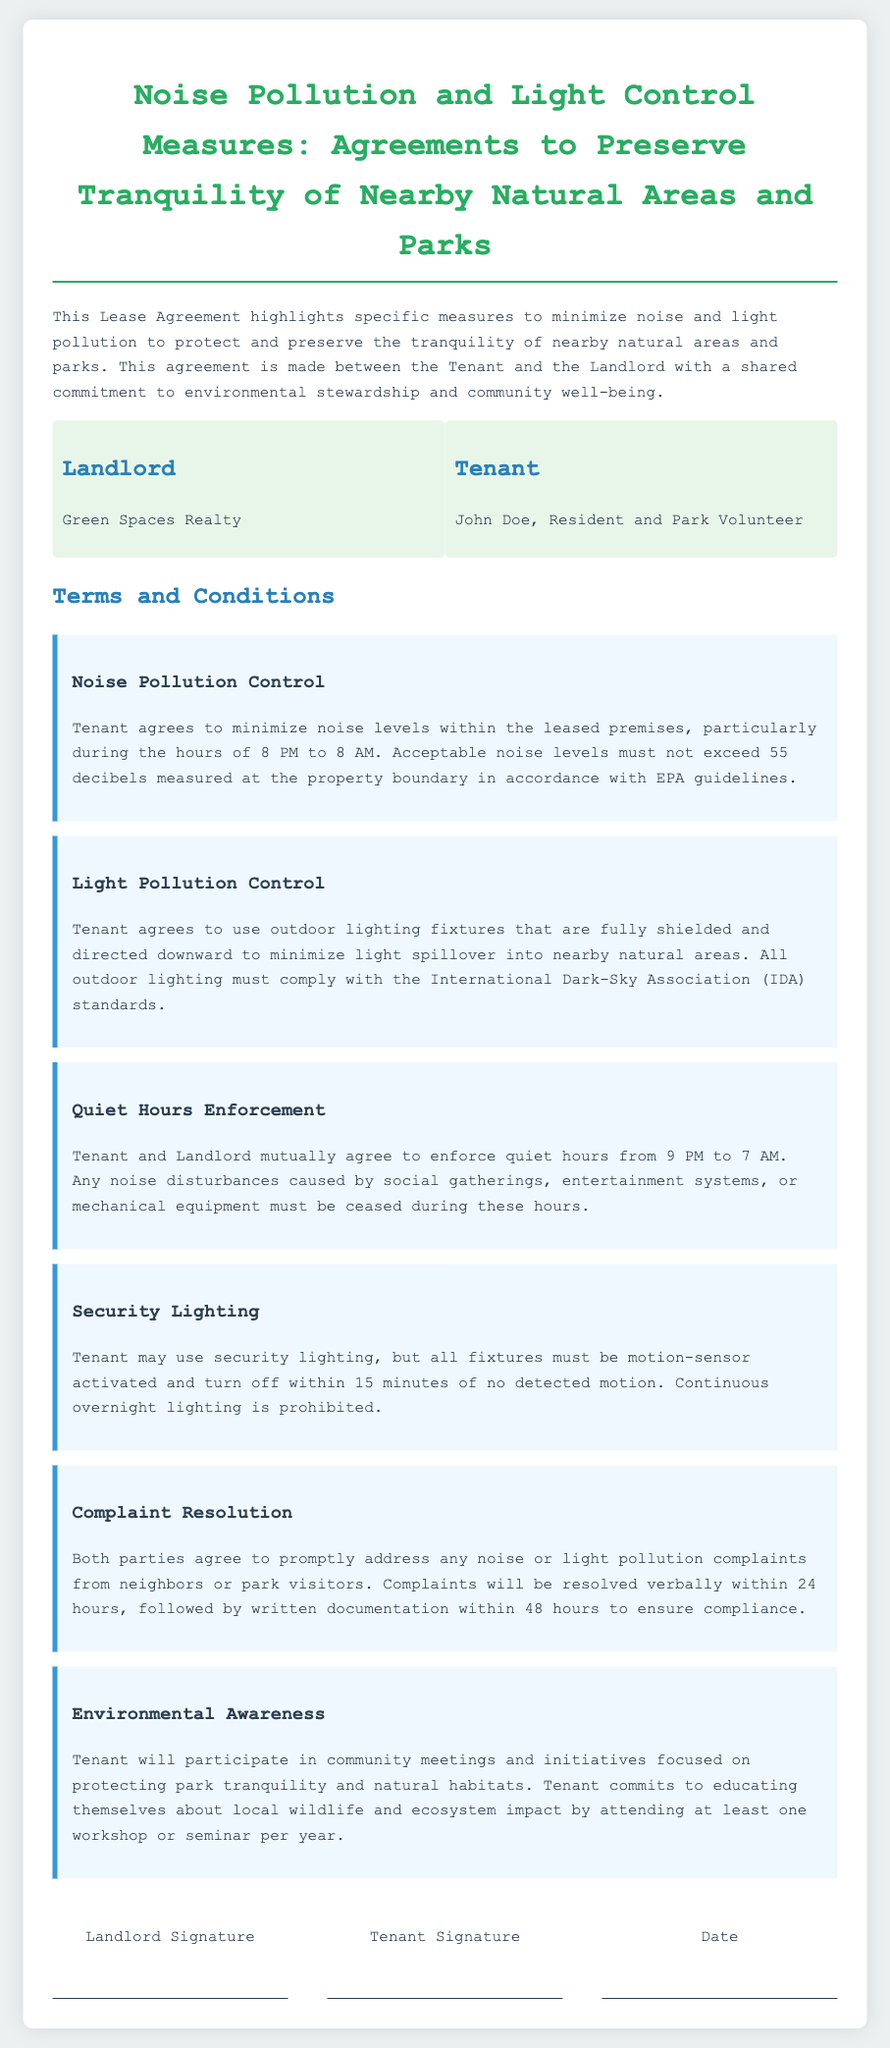What is the landlord's name? The landlord's name is mentioned in the parties section of the document, which is Green Spaces Realty.
Answer: Green Spaces Realty What hours are defined as quiet hours? The quiet hours are explicitly stated in the document, which are from 9 PM to 7 AM.
Answer: 9 PM to 7 AM What is the acceptable noise level limit according to EPA guidelines? The acceptable noise level limit is provided in the Noise Pollution Control clause, indicating it should not exceed 55 decibels.
Answer: 55 decibels What type of lighting fixtures must the tenant use? The document specifies that outdoor lighting fixtures must be fully shielded and directed downward to minimize light spillover.
Answer: Fully shielded and directed downward How soon must complaints be resolved verbally? The Complaint Resolution clause specifies that complaints will be resolved verbally within 24 hours.
Answer: 24 hours What is the security lighting rule regarding motion detection? The rule states that security lighting fixtures must be motion-sensor activated and turn off within 15 minutes of no detected motion.
Answer: 15 minutes How many workshops or seminars must the tenant attend per year? The Environmental Awareness clause states the tenant commits to attending at least one workshop or seminar per year.
Answer: One Who signs the lease agreement? The lease agreement is signed by the landlord and tenant, who are Green Spaces Realty and John Doe, respectively.
Answer: Green Spaces Realty and John Doe 